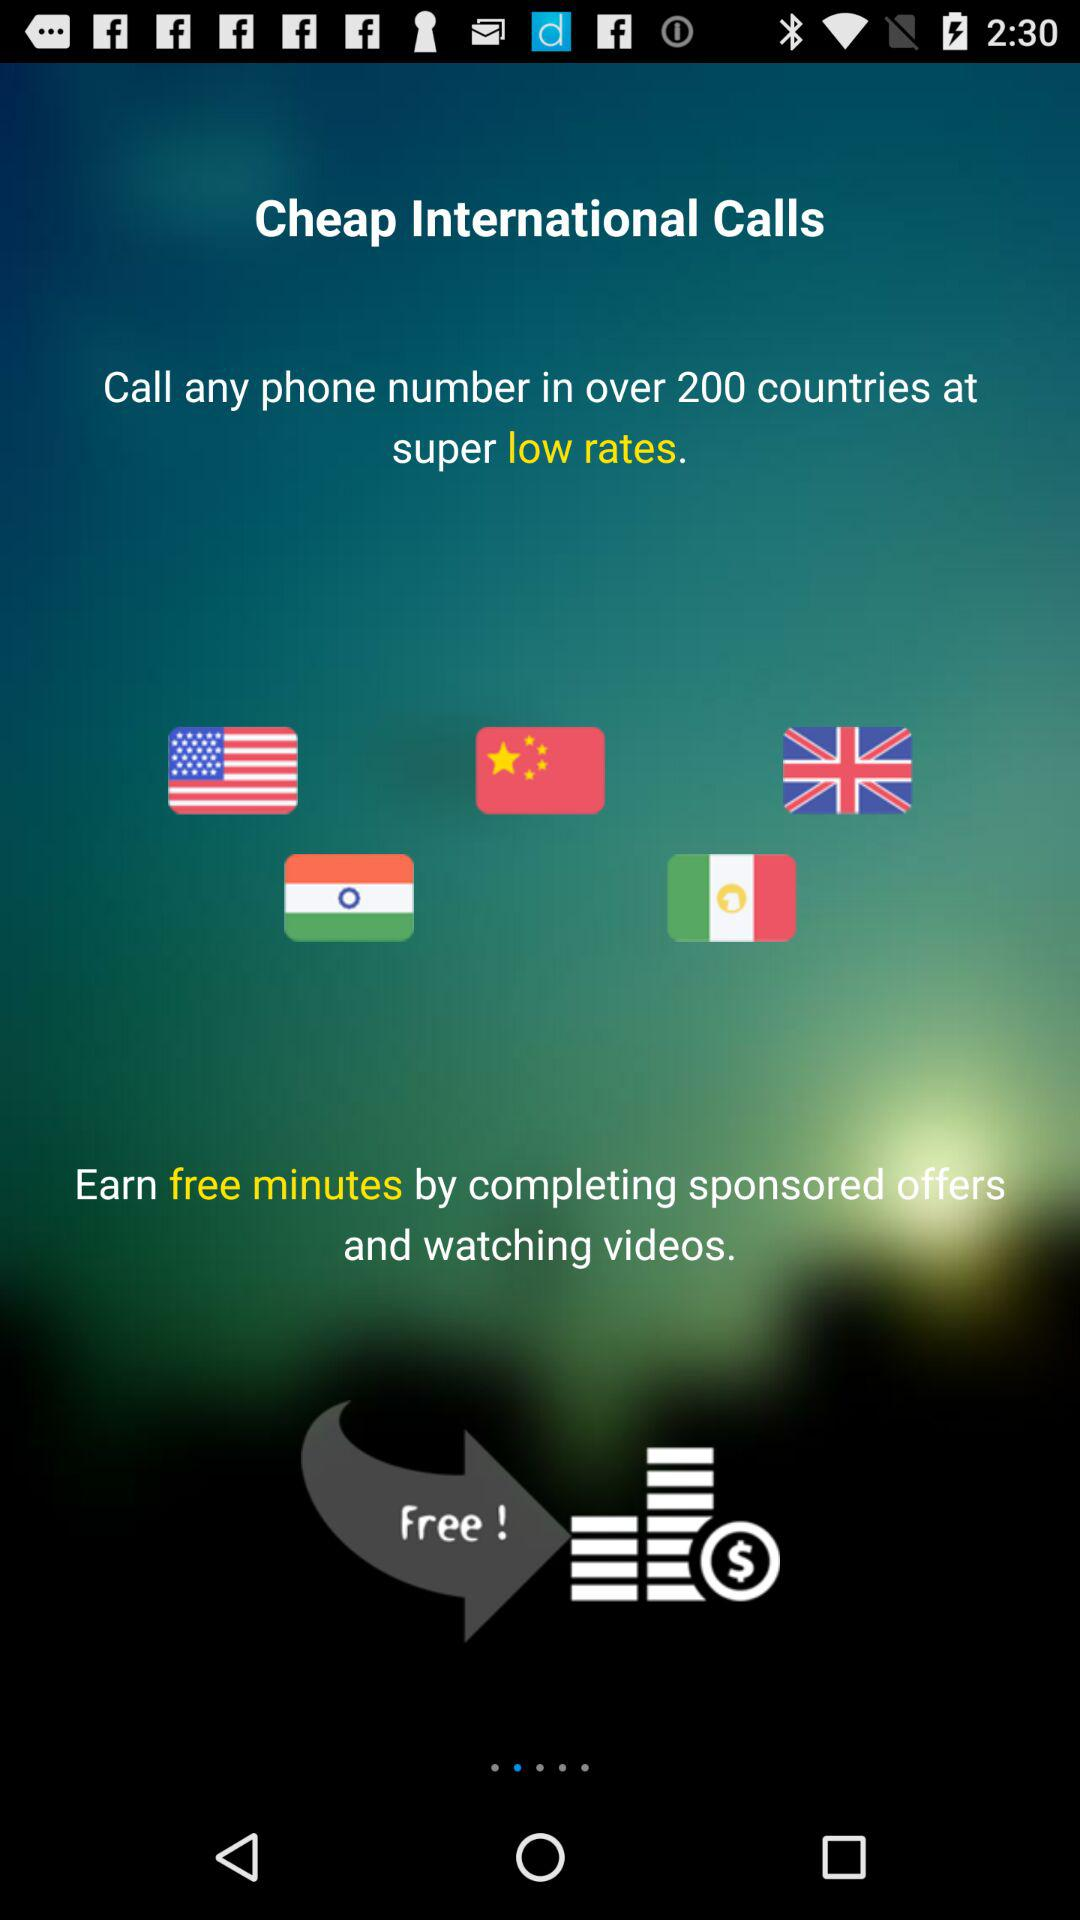How many total countries are there? There are over 200 countries in total. 